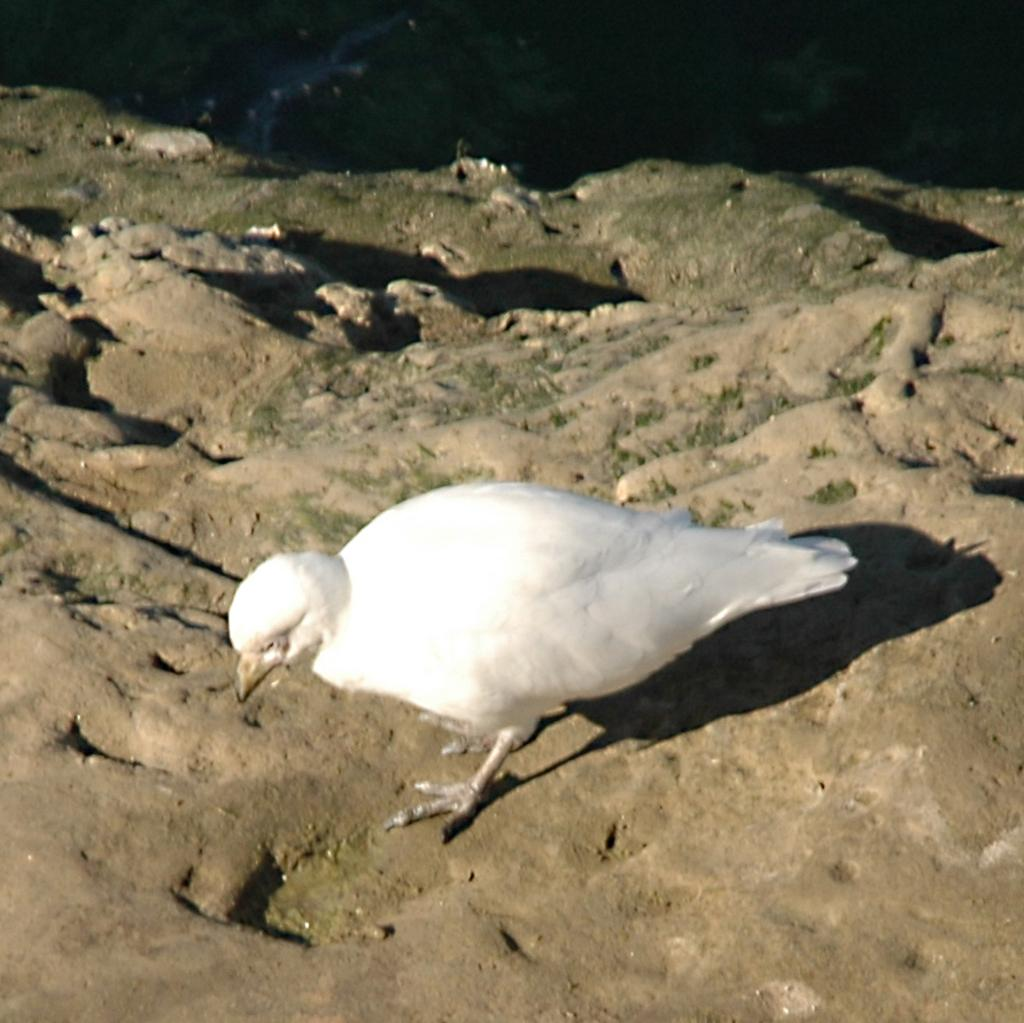What type of animal can be seen in the image? There is a white-colored bird in the image. What else can be observed in the image besides the bird? Shadows are visible in the image. What type of cream is being used by the actor in the image? There is no actor or cream present in the image; it features a white-colored bird and shadows. What appliance is being used by the bird in the image? There is no appliance present in the image; it features a white-colored bird and shadows. 